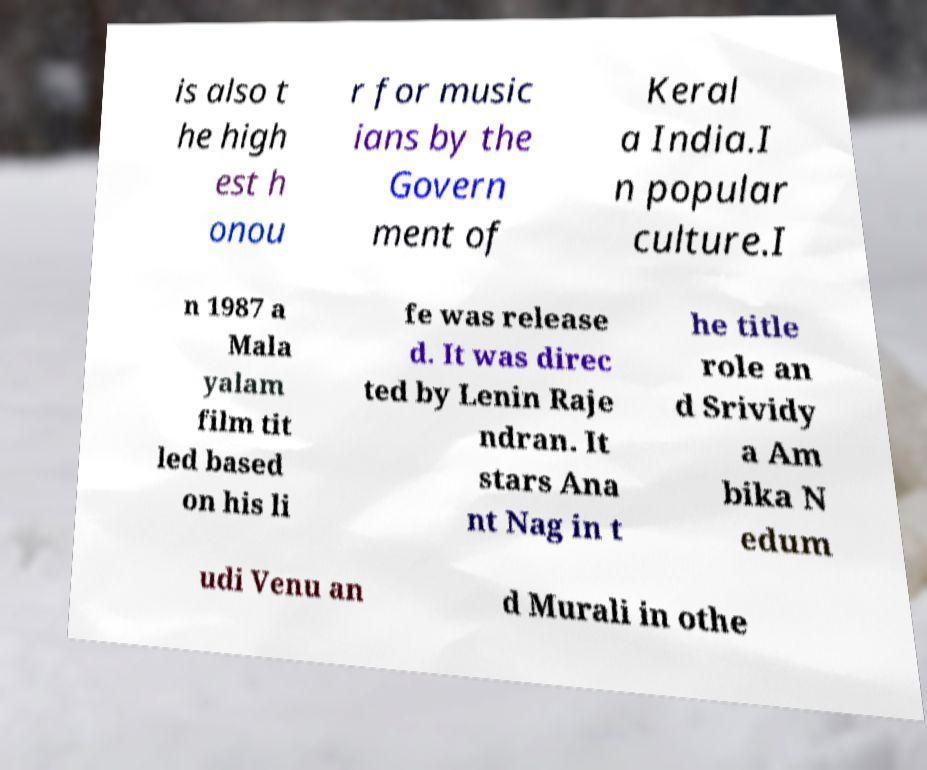For documentation purposes, I need the text within this image transcribed. Could you provide that? is also t he high est h onou r for music ians by the Govern ment of Keral a India.I n popular culture.I n 1987 a Mala yalam film tit led based on his li fe was release d. It was direc ted by Lenin Raje ndran. It stars Ana nt Nag in t he title role an d Srividy a Am bika N edum udi Venu an d Murali in othe 